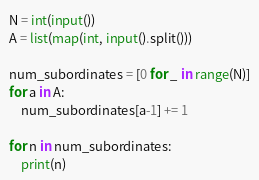<code> <loc_0><loc_0><loc_500><loc_500><_Python_>N = int(input())
A = list(map(int, input().split()))

num_subordinates = [0 for _ in range(N)]
for a in A:
	num_subordinates[a-1] += 1

for n in num_subordinates:
	print(n)</code> 